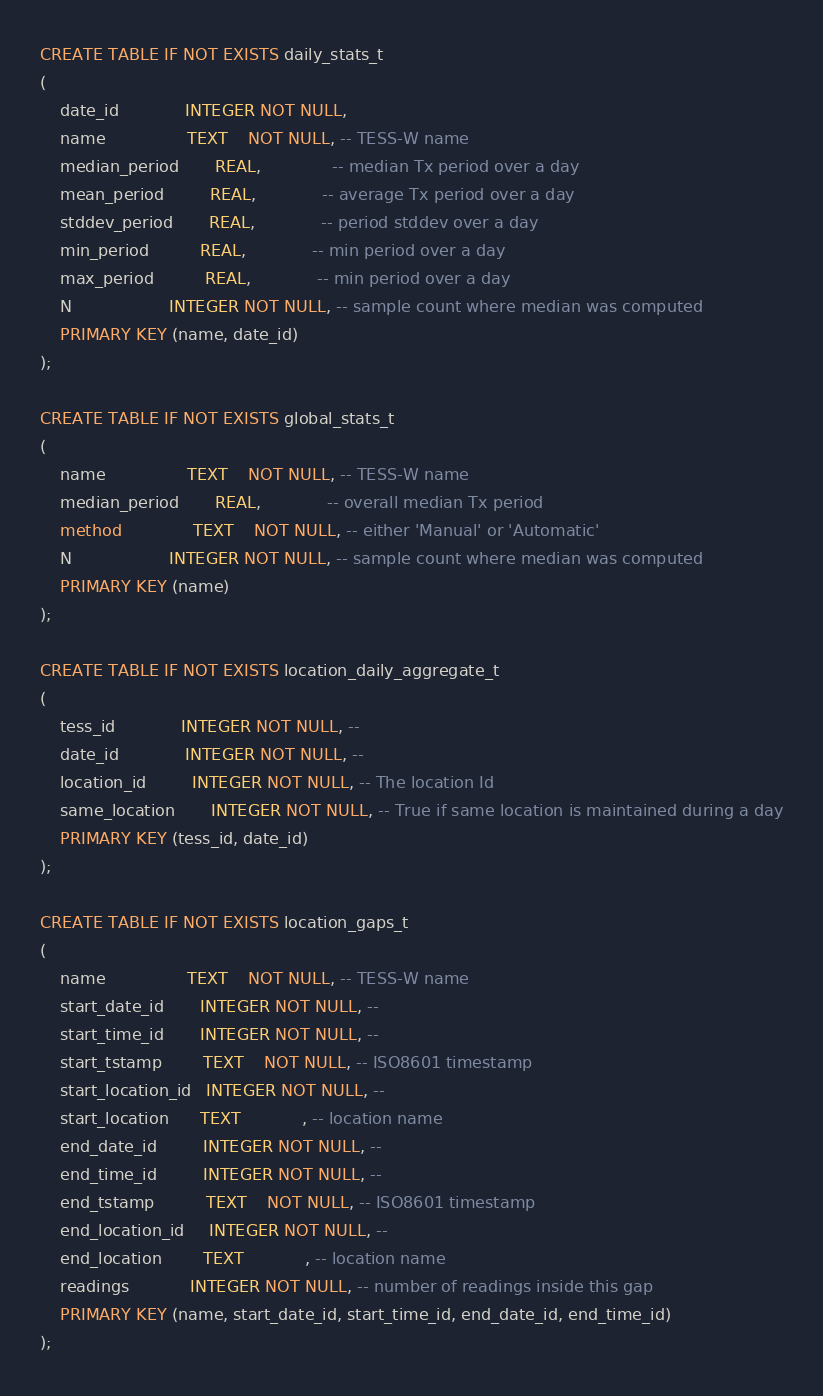<code> <loc_0><loc_0><loc_500><loc_500><_SQL_>
CREATE TABLE IF NOT EXISTS daily_stats_t
(
	date_id             INTEGER NOT NULL, 
	name                TEXT    NOT NULL, -- TESS-W name
	median_period       REAL,	          -- median Tx period over a day
	mean_period         REAL,             -- average Tx period over a day
	stddev_period       REAL,             -- period stddev over a day
    min_period          REAL,             -- min period over a day
    max_period          REAL,             -- min period over a day
    N                   INTEGER NOT NULL, -- sample count where median was computed
	PRIMARY KEY (name, date_id)
);

CREATE TABLE IF NOT EXISTS global_stats_t
( 
    name                TEXT    NOT NULL, -- TESS-W name
    median_period       REAL,             -- overall median Tx period
    method              TEXT    NOT NULL, -- either 'Manual' or 'Automatic'
    N                   INTEGER NOT NULL, -- sample count where median was computed
    PRIMARY KEY (name)
);

CREATE TABLE IF NOT EXISTS location_daily_aggregate_t
( 
    tess_id             INTEGER NOT NULL, -- 
    date_id             INTEGER NOT NULL, --
    location_id         INTEGER NOT NULL, -- The location Id
    same_location       INTEGER NOT NULL, -- True if same location is maintained during a day
    PRIMARY KEY (tess_id, date_id)
);

CREATE TABLE IF NOT EXISTS location_gaps_t
( 
    name                TEXT    NOT NULL, -- TESS-W name
    start_date_id       INTEGER NOT NULL, --
    start_time_id       INTEGER NOT NULL, --
    start_tstamp        TEXT    NOT NULL, -- ISO8601 timestamp
    start_location_id   INTEGER NOT NULL, -- 
    start_location      TEXT            , -- location name
    end_date_id         INTEGER NOT NULL, --
    end_time_id         INTEGER NOT NULL, --
    end_tstamp          TEXT    NOT NULL, -- ISO8601 timestamp
    end_location_id     INTEGER NOT NULL, -- 
    end_location        TEXT            , -- location name
    readings            INTEGER NOT NULL, -- number of readings inside this gap
    PRIMARY KEY (name, start_date_id, start_time_id, end_date_id, end_time_id)
);</code> 